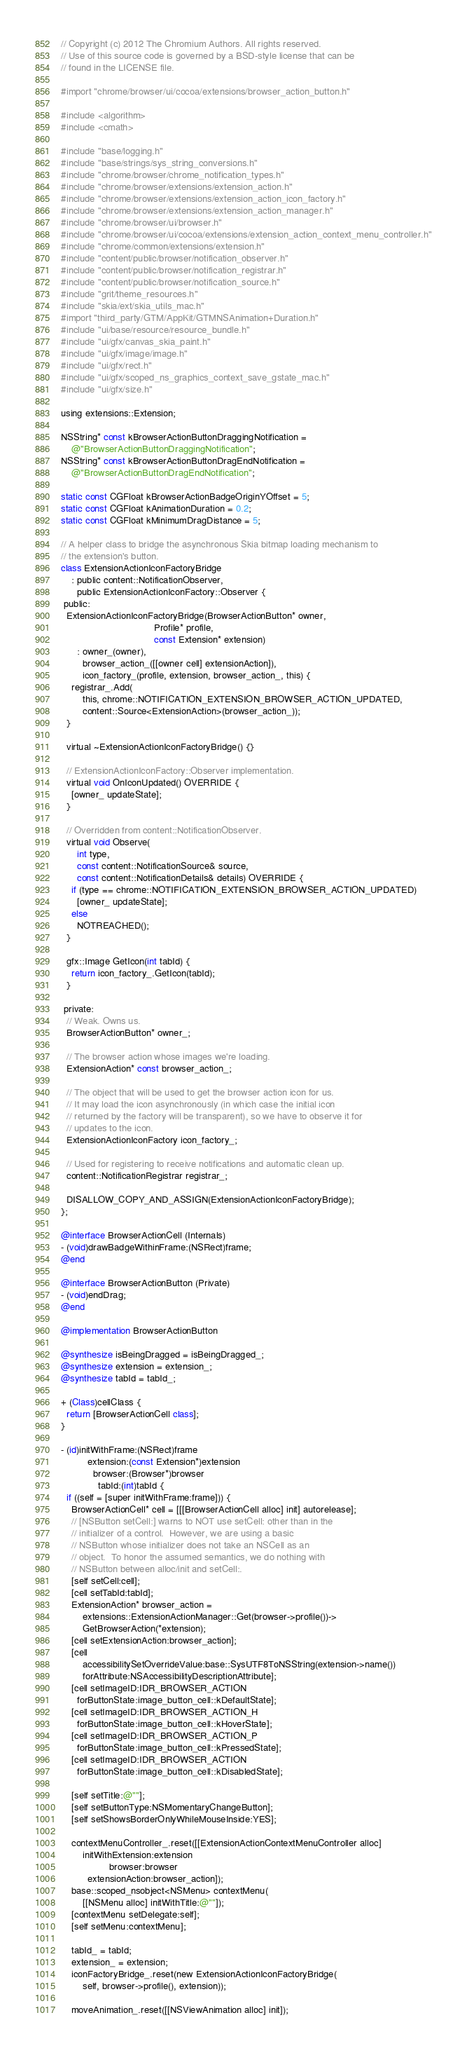Convert code to text. <code><loc_0><loc_0><loc_500><loc_500><_ObjectiveC_>// Copyright (c) 2012 The Chromium Authors. All rights reserved.
// Use of this source code is governed by a BSD-style license that can be
// found in the LICENSE file.

#import "chrome/browser/ui/cocoa/extensions/browser_action_button.h"

#include <algorithm>
#include <cmath>

#include "base/logging.h"
#include "base/strings/sys_string_conversions.h"
#include "chrome/browser/chrome_notification_types.h"
#include "chrome/browser/extensions/extension_action.h"
#include "chrome/browser/extensions/extension_action_icon_factory.h"
#include "chrome/browser/extensions/extension_action_manager.h"
#include "chrome/browser/ui/browser.h"
#include "chrome/browser/ui/cocoa/extensions/extension_action_context_menu_controller.h"
#include "chrome/common/extensions/extension.h"
#include "content/public/browser/notification_observer.h"
#include "content/public/browser/notification_registrar.h"
#include "content/public/browser/notification_source.h"
#include "grit/theme_resources.h"
#include "skia/ext/skia_utils_mac.h"
#import "third_party/GTM/AppKit/GTMNSAnimation+Duration.h"
#include "ui/base/resource/resource_bundle.h"
#include "ui/gfx/canvas_skia_paint.h"
#include "ui/gfx/image/image.h"
#include "ui/gfx/rect.h"
#include "ui/gfx/scoped_ns_graphics_context_save_gstate_mac.h"
#include "ui/gfx/size.h"

using extensions::Extension;

NSString* const kBrowserActionButtonDraggingNotification =
    @"BrowserActionButtonDraggingNotification";
NSString* const kBrowserActionButtonDragEndNotification =
    @"BrowserActionButtonDragEndNotification";

static const CGFloat kBrowserActionBadgeOriginYOffset = 5;
static const CGFloat kAnimationDuration = 0.2;
static const CGFloat kMinimumDragDistance = 5;

// A helper class to bridge the asynchronous Skia bitmap loading mechanism to
// the extension's button.
class ExtensionActionIconFactoryBridge
    : public content::NotificationObserver,
      public ExtensionActionIconFactory::Observer {
 public:
  ExtensionActionIconFactoryBridge(BrowserActionButton* owner,
                                   Profile* profile,
                                   const Extension* extension)
      : owner_(owner),
        browser_action_([[owner cell] extensionAction]),
        icon_factory_(profile, extension, browser_action_, this) {
    registrar_.Add(
        this, chrome::NOTIFICATION_EXTENSION_BROWSER_ACTION_UPDATED,
        content::Source<ExtensionAction>(browser_action_));
  }

  virtual ~ExtensionActionIconFactoryBridge() {}

  // ExtensionActionIconFactory::Observer implementation.
  virtual void OnIconUpdated() OVERRIDE {
    [owner_ updateState];
  }

  // Overridden from content::NotificationObserver.
  virtual void Observe(
      int type,
      const content::NotificationSource& source,
      const content::NotificationDetails& details) OVERRIDE {
    if (type == chrome::NOTIFICATION_EXTENSION_BROWSER_ACTION_UPDATED)
      [owner_ updateState];
    else
      NOTREACHED();
  }

  gfx::Image GetIcon(int tabId) {
    return icon_factory_.GetIcon(tabId);
  }

 private:
  // Weak. Owns us.
  BrowserActionButton* owner_;

  // The browser action whose images we're loading.
  ExtensionAction* const browser_action_;

  // The object that will be used to get the browser action icon for us.
  // It may load the icon asynchronously (in which case the initial icon
  // returned by the factory will be transparent), so we have to observe it for
  // updates to the icon.
  ExtensionActionIconFactory icon_factory_;

  // Used for registering to receive notifications and automatic clean up.
  content::NotificationRegistrar registrar_;

  DISALLOW_COPY_AND_ASSIGN(ExtensionActionIconFactoryBridge);
};

@interface BrowserActionCell (Internals)
- (void)drawBadgeWithinFrame:(NSRect)frame;
@end

@interface BrowserActionButton (Private)
- (void)endDrag;
@end

@implementation BrowserActionButton

@synthesize isBeingDragged = isBeingDragged_;
@synthesize extension = extension_;
@synthesize tabId = tabId_;

+ (Class)cellClass {
  return [BrowserActionCell class];
}

- (id)initWithFrame:(NSRect)frame
          extension:(const Extension*)extension
            browser:(Browser*)browser
              tabId:(int)tabId {
  if ((self = [super initWithFrame:frame])) {
    BrowserActionCell* cell = [[[BrowserActionCell alloc] init] autorelease];
    // [NSButton setCell:] warns to NOT use setCell: other than in the
    // initializer of a control.  However, we are using a basic
    // NSButton whose initializer does not take an NSCell as an
    // object.  To honor the assumed semantics, we do nothing with
    // NSButton between alloc/init and setCell:.
    [self setCell:cell];
    [cell setTabId:tabId];
    ExtensionAction* browser_action =
        extensions::ExtensionActionManager::Get(browser->profile())->
        GetBrowserAction(*extension);
    [cell setExtensionAction:browser_action];
    [cell
        accessibilitySetOverrideValue:base::SysUTF8ToNSString(extension->name())
        forAttribute:NSAccessibilityDescriptionAttribute];
    [cell setImageID:IDR_BROWSER_ACTION
      forButtonState:image_button_cell::kDefaultState];
    [cell setImageID:IDR_BROWSER_ACTION_H
      forButtonState:image_button_cell::kHoverState];
    [cell setImageID:IDR_BROWSER_ACTION_P
      forButtonState:image_button_cell::kPressedState];
    [cell setImageID:IDR_BROWSER_ACTION
      forButtonState:image_button_cell::kDisabledState];

    [self setTitle:@""];
    [self setButtonType:NSMomentaryChangeButton];
    [self setShowsBorderOnlyWhileMouseInside:YES];

    contextMenuController_.reset([[ExtensionActionContextMenuController alloc]
        initWithExtension:extension
                  browser:browser
          extensionAction:browser_action]);
    base::scoped_nsobject<NSMenu> contextMenu(
        [[NSMenu alloc] initWithTitle:@""]);
    [contextMenu setDelegate:self];
    [self setMenu:contextMenu];

    tabId_ = tabId;
    extension_ = extension;
    iconFactoryBridge_.reset(new ExtensionActionIconFactoryBridge(
        self, browser->profile(), extension));

    moveAnimation_.reset([[NSViewAnimation alloc] init]);</code> 